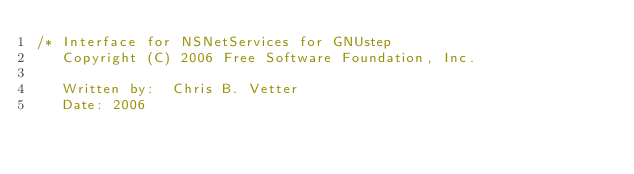Convert code to text. <code><loc_0><loc_0><loc_500><loc_500><_C_>/* Interface for NSNetServices for GNUstep
   Copyright (C) 2006 Free Software Foundation, Inc.

   Written by:  Chris B. Vetter
   Date: 2006
   </code> 